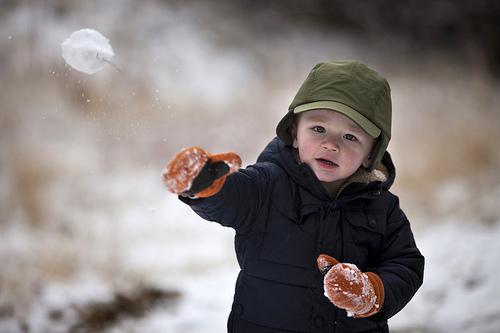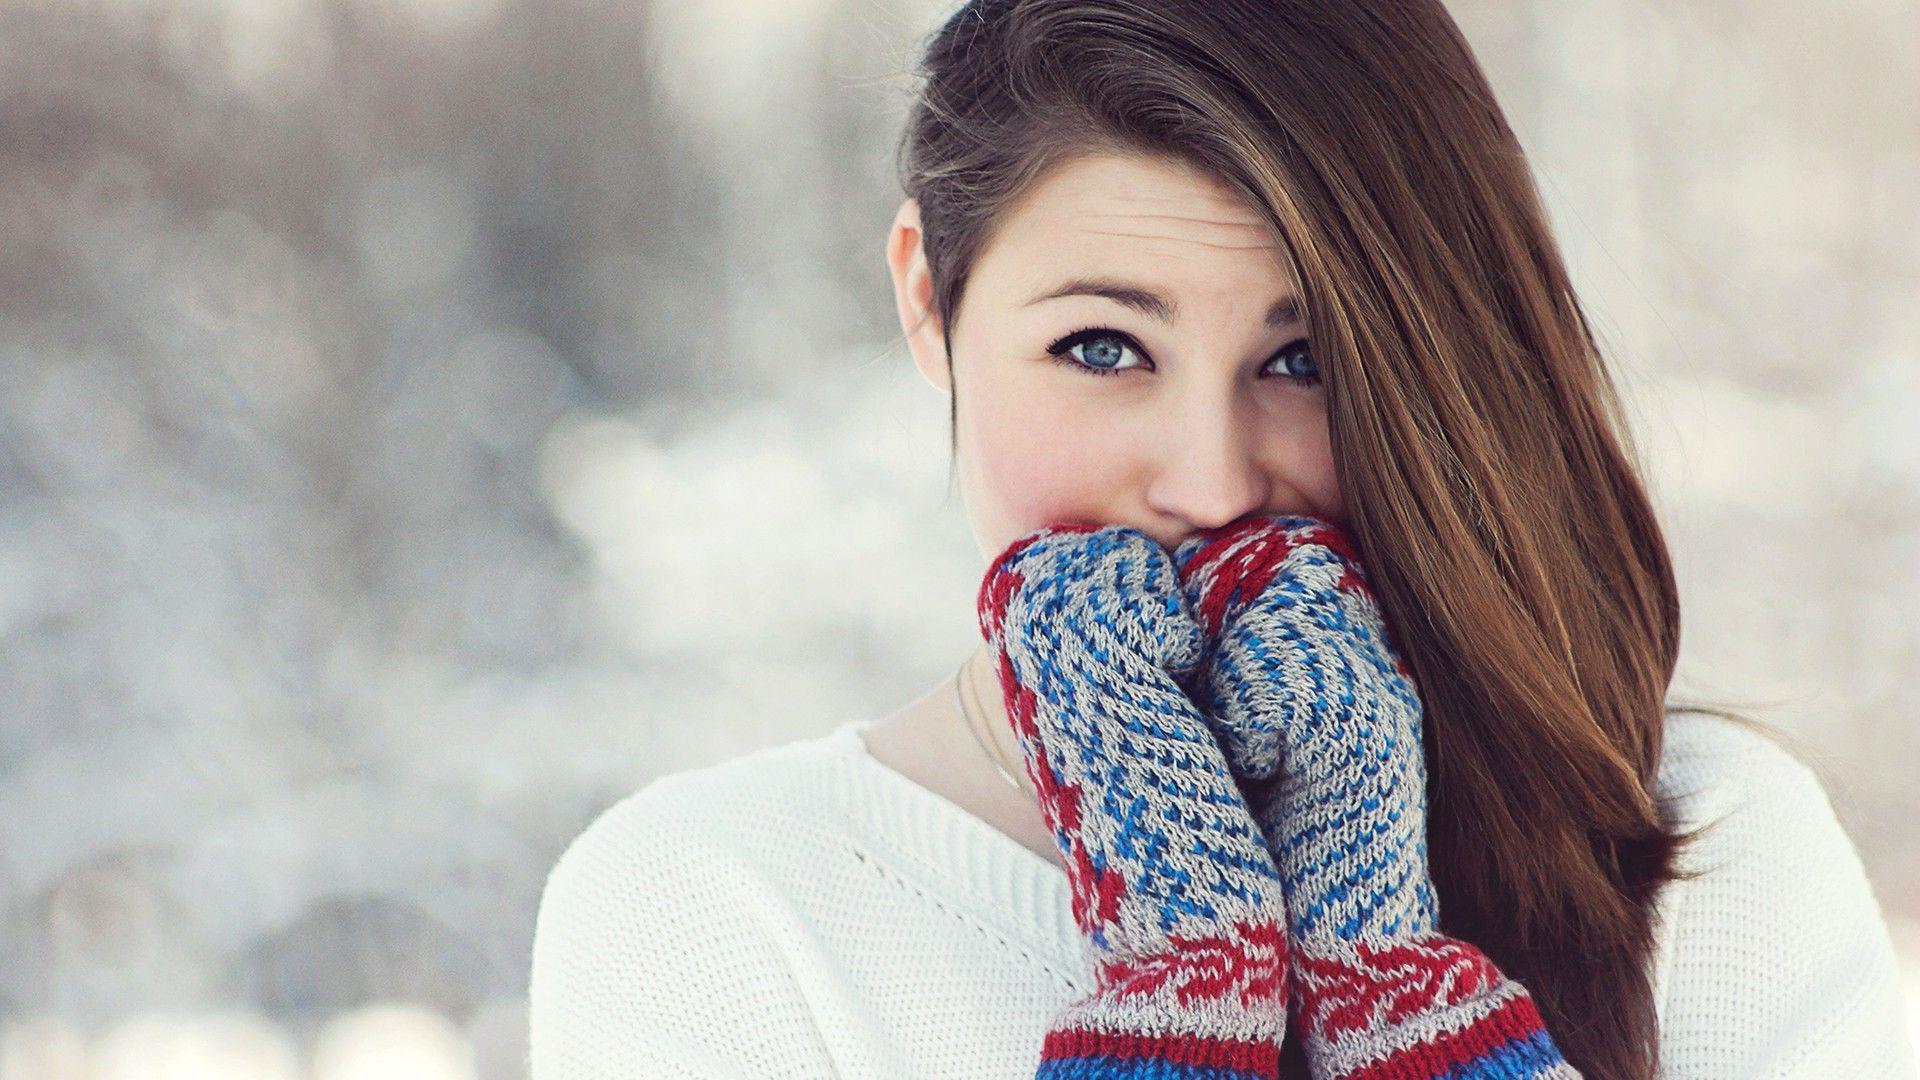The first image is the image on the left, the second image is the image on the right. For the images displayed, is the sentence "There are three mittens in each set of images, and they are all solid colors" factually correct? Answer yes or no. No. The first image is the image on the left, the second image is the image on the right. Examine the images to the left and right. Is the description "You can see someone's eyes in every single image." accurate? Answer yes or no. Yes. 